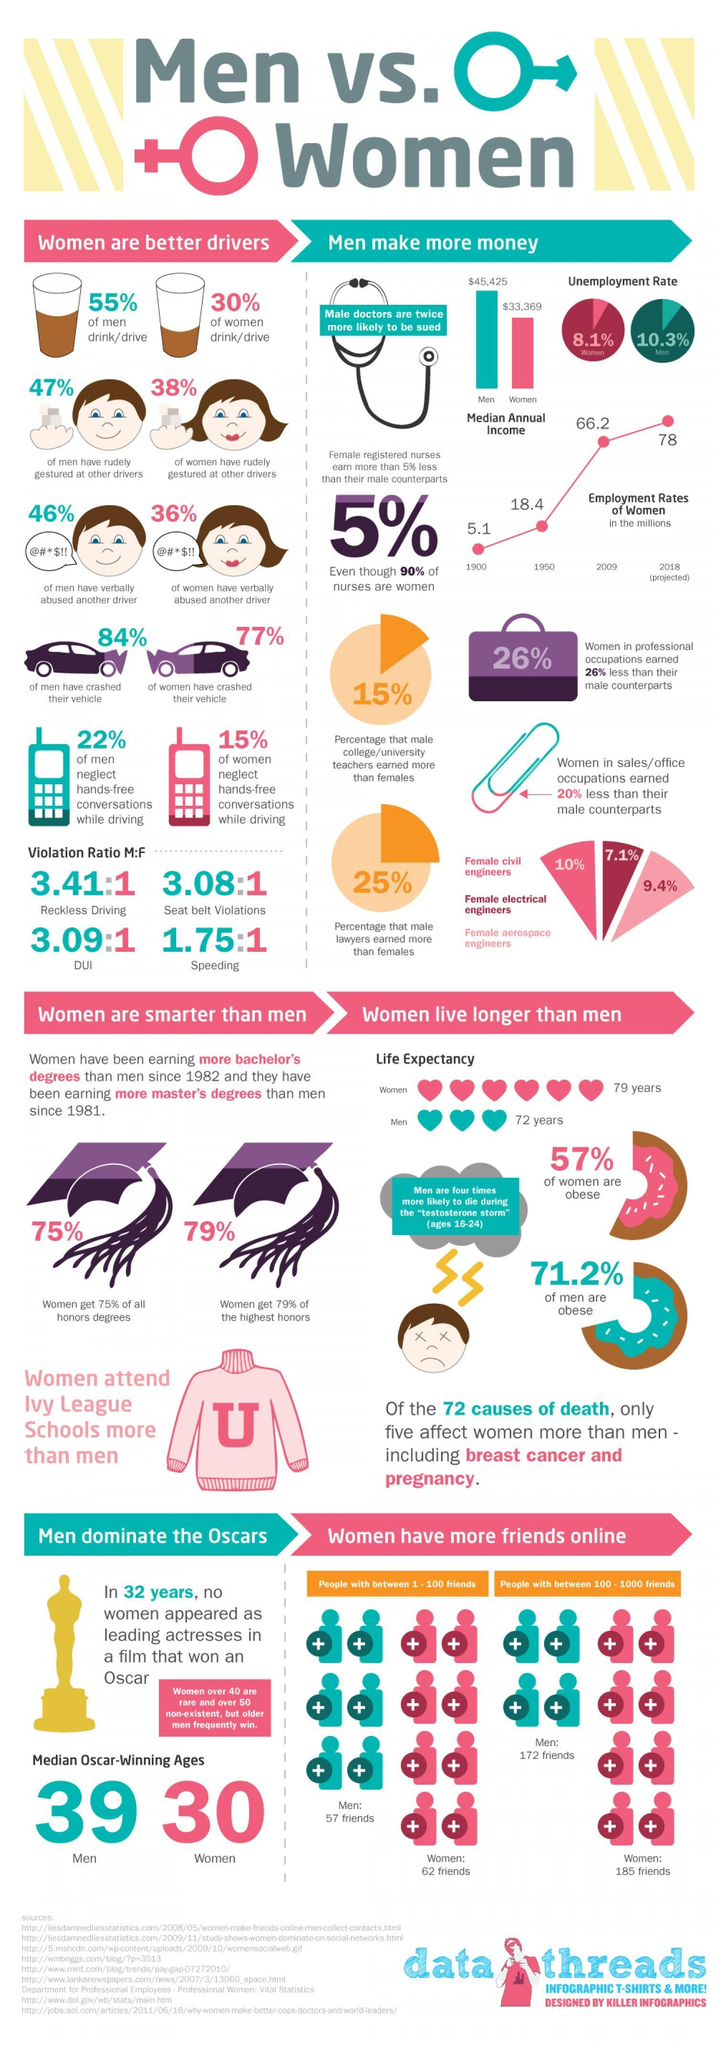What is the percentage of women aerospace engineers, 10%, 7.1%, or 9.4%?
Answer the question with a short phrase. 9.4% How much more percentage of pay do men in sales earn than women, 22%, 15%, or 20%? 20% What constitutes to the lowest violation ratio in men? Speeding Which field has the lowest representation of women in percentage, civil engineering, electrical engineering, or aerospace engineering? electrical engineering 